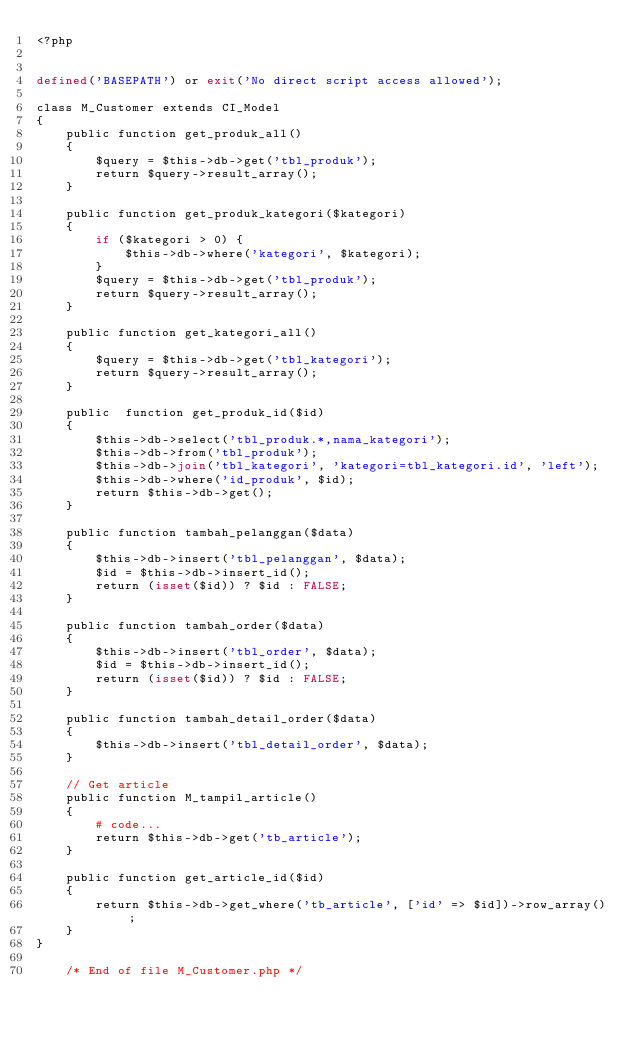Convert code to text. <code><loc_0><loc_0><loc_500><loc_500><_PHP_><?php


defined('BASEPATH') or exit('No direct script access allowed');

class M_Customer extends CI_Model
{
    public function get_produk_all()
    {
        $query = $this->db->get('tbl_produk');
        return $query->result_array();
    }

    public function get_produk_kategori($kategori)
    {
        if ($kategori > 0) {
            $this->db->where('kategori', $kategori);
        }
        $query = $this->db->get('tbl_produk');
        return $query->result_array();
    }

    public function get_kategori_all()
    {
        $query = $this->db->get('tbl_kategori');
        return $query->result_array();
    }

    public  function get_produk_id($id)
    {
        $this->db->select('tbl_produk.*,nama_kategori');
        $this->db->from('tbl_produk');
        $this->db->join('tbl_kategori', 'kategori=tbl_kategori.id', 'left');
        $this->db->where('id_produk', $id);
        return $this->db->get();
    }

    public function tambah_pelanggan($data)
    {
        $this->db->insert('tbl_pelanggan', $data);
        $id = $this->db->insert_id();
        return (isset($id)) ? $id : FALSE;
    }

    public function tambah_order($data)
    {
        $this->db->insert('tbl_order', $data);
        $id = $this->db->insert_id();
        return (isset($id)) ? $id : FALSE;
    }

    public function tambah_detail_order($data)
    {
        $this->db->insert('tbl_detail_order', $data);
    }

    // Get article 
    public function M_tampil_article()
    {
        # code...
        return $this->db->get('tb_article');
    }

    public function get_article_id($id)
    {
        return $this->db->get_where('tb_article', ['id' => $id])->row_array();
    }
}
    
    /* End of file M_Customer.php */
</code> 